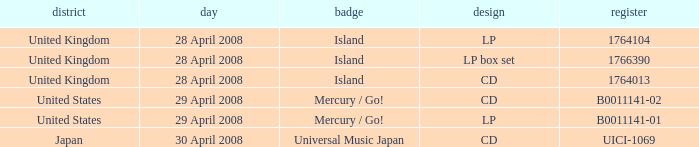What is the Region of the 1766390 Catalog? United Kingdom. 